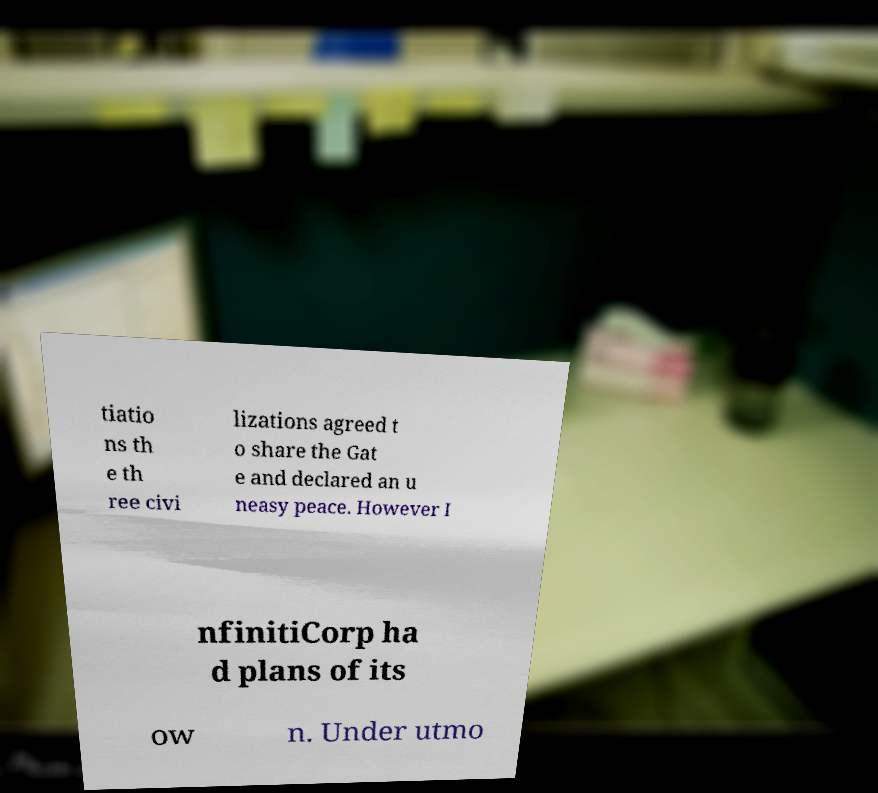Can you read and provide the text displayed in the image?This photo seems to have some interesting text. Can you extract and type it out for me? tiatio ns th e th ree civi lizations agreed t o share the Gat e and declared an u neasy peace. However I nfinitiCorp ha d plans of its ow n. Under utmo 